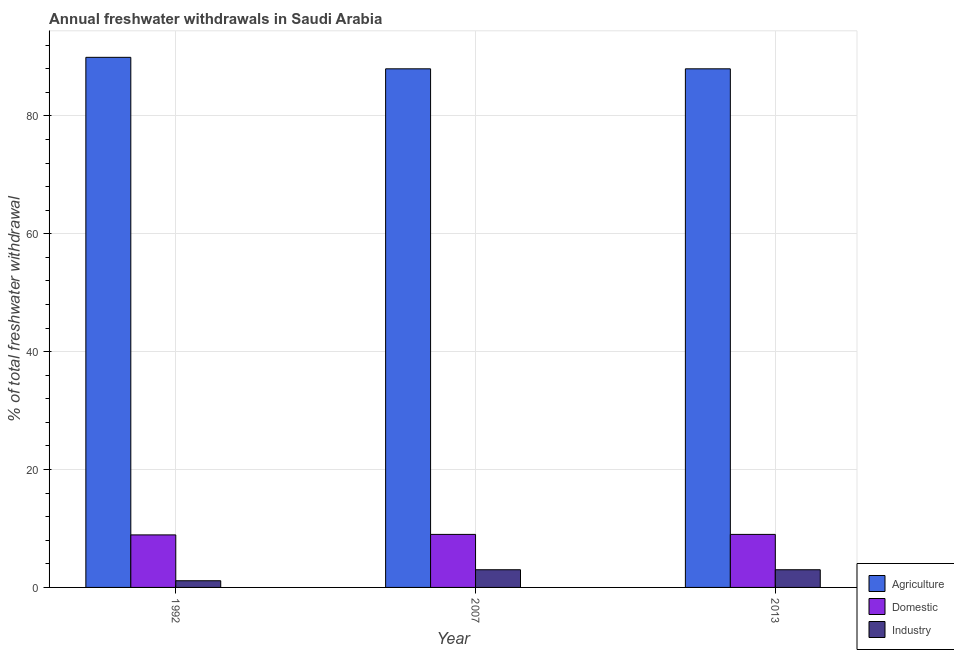How many different coloured bars are there?
Offer a very short reply. 3. Are the number of bars per tick equal to the number of legend labels?
Your response must be concise. Yes. How many bars are there on the 1st tick from the right?
Your answer should be compact. 3. What is the label of the 1st group of bars from the left?
Your response must be concise. 1992. In how many cases, is the number of bars for a given year not equal to the number of legend labels?
Your answer should be very brief. 0. Across all years, what is the maximum percentage of freshwater withdrawal for agriculture?
Keep it short and to the point. 89.95. Across all years, what is the minimum percentage of freshwater withdrawal for industry?
Make the answer very short. 1.13. In which year was the percentage of freshwater withdrawal for industry maximum?
Offer a terse response. 2007. What is the total percentage of freshwater withdrawal for industry in the graph?
Make the answer very short. 7.13. What is the difference between the percentage of freshwater withdrawal for agriculture in 1992 and that in 2013?
Provide a succinct answer. 1.95. What is the difference between the percentage of freshwater withdrawal for industry in 2007 and the percentage of freshwater withdrawal for domestic purposes in 2013?
Make the answer very short. 0. What is the average percentage of freshwater withdrawal for agriculture per year?
Make the answer very short. 88.65. What is the difference between the highest and the second highest percentage of freshwater withdrawal for industry?
Offer a very short reply. 0. What is the difference between the highest and the lowest percentage of freshwater withdrawal for industry?
Keep it short and to the point. 1.87. What does the 3rd bar from the left in 1992 represents?
Offer a terse response. Industry. What does the 3rd bar from the right in 1992 represents?
Your response must be concise. Agriculture. How many bars are there?
Make the answer very short. 9. How many years are there in the graph?
Offer a very short reply. 3. What is the difference between two consecutive major ticks on the Y-axis?
Your answer should be compact. 20. Does the graph contain any zero values?
Keep it short and to the point. No. Does the graph contain grids?
Offer a terse response. Yes. Where does the legend appear in the graph?
Make the answer very short. Bottom right. How many legend labels are there?
Your response must be concise. 3. What is the title of the graph?
Keep it short and to the point. Annual freshwater withdrawals in Saudi Arabia. What is the label or title of the Y-axis?
Provide a short and direct response. % of total freshwater withdrawal. What is the % of total freshwater withdrawal of Agriculture in 1992?
Provide a short and direct response. 89.95. What is the % of total freshwater withdrawal of Domestic in 1992?
Make the answer very short. 8.91. What is the % of total freshwater withdrawal of Industry in 1992?
Make the answer very short. 1.13. What is the % of total freshwater withdrawal of Agriculture in 2007?
Provide a succinct answer. 88. What is the % of total freshwater withdrawal of Domestic in 2007?
Ensure brevity in your answer.  9. What is the % of total freshwater withdrawal of Industry in 2007?
Keep it short and to the point. 3. What is the % of total freshwater withdrawal in Agriculture in 2013?
Offer a very short reply. 88. What is the % of total freshwater withdrawal of Domestic in 2013?
Make the answer very short. 9. What is the % of total freshwater withdrawal of Industry in 2013?
Make the answer very short. 3. Across all years, what is the maximum % of total freshwater withdrawal of Agriculture?
Provide a short and direct response. 89.95. Across all years, what is the maximum % of total freshwater withdrawal in Domestic?
Make the answer very short. 9. Across all years, what is the minimum % of total freshwater withdrawal in Agriculture?
Your answer should be very brief. 88. Across all years, what is the minimum % of total freshwater withdrawal of Domestic?
Your response must be concise. 8.91. Across all years, what is the minimum % of total freshwater withdrawal of Industry?
Give a very brief answer. 1.13. What is the total % of total freshwater withdrawal of Agriculture in the graph?
Provide a succinct answer. 265.95. What is the total % of total freshwater withdrawal of Domestic in the graph?
Provide a short and direct response. 26.91. What is the total % of total freshwater withdrawal of Industry in the graph?
Your answer should be compact. 7.13. What is the difference between the % of total freshwater withdrawal of Agriculture in 1992 and that in 2007?
Your answer should be very brief. 1.95. What is the difference between the % of total freshwater withdrawal of Domestic in 1992 and that in 2007?
Offer a terse response. -0.09. What is the difference between the % of total freshwater withdrawal in Industry in 1992 and that in 2007?
Your answer should be very brief. -1.87. What is the difference between the % of total freshwater withdrawal of Agriculture in 1992 and that in 2013?
Offer a terse response. 1.95. What is the difference between the % of total freshwater withdrawal in Domestic in 1992 and that in 2013?
Offer a terse response. -0.09. What is the difference between the % of total freshwater withdrawal of Industry in 1992 and that in 2013?
Offer a very short reply. -1.87. What is the difference between the % of total freshwater withdrawal of Agriculture in 2007 and that in 2013?
Provide a succinct answer. 0. What is the difference between the % of total freshwater withdrawal in Industry in 2007 and that in 2013?
Provide a short and direct response. 0. What is the difference between the % of total freshwater withdrawal in Agriculture in 1992 and the % of total freshwater withdrawal in Domestic in 2007?
Offer a very short reply. 80.95. What is the difference between the % of total freshwater withdrawal of Agriculture in 1992 and the % of total freshwater withdrawal of Industry in 2007?
Keep it short and to the point. 86.95. What is the difference between the % of total freshwater withdrawal in Domestic in 1992 and the % of total freshwater withdrawal in Industry in 2007?
Your answer should be very brief. 5.91. What is the difference between the % of total freshwater withdrawal of Agriculture in 1992 and the % of total freshwater withdrawal of Domestic in 2013?
Your answer should be very brief. 80.95. What is the difference between the % of total freshwater withdrawal of Agriculture in 1992 and the % of total freshwater withdrawal of Industry in 2013?
Your answer should be compact. 86.95. What is the difference between the % of total freshwater withdrawal in Domestic in 1992 and the % of total freshwater withdrawal in Industry in 2013?
Provide a succinct answer. 5.91. What is the difference between the % of total freshwater withdrawal in Agriculture in 2007 and the % of total freshwater withdrawal in Domestic in 2013?
Keep it short and to the point. 79. What is the difference between the % of total freshwater withdrawal in Domestic in 2007 and the % of total freshwater withdrawal in Industry in 2013?
Ensure brevity in your answer.  6. What is the average % of total freshwater withdrawal of Agriculture per year?
Provide a short and direct response. 88.65. What is the average % of total freshwater withdrawal of Domestic per year?
Provide a short and direct response. 8.97. What is the average % of total freshwater withdrawal of Industry per year?
Give a very brief answer. 2.38. In the year 1992, what is the difference between the % of total freshwater withdrawal in Agriculture and % of total freshwater withdrawal in Domestic?
Your response must be concise. 81.04. In the year 1992, what is the difference between the % of total freshwater withdrawal in Agriculture and % of total freshwater withdrawal in Industry?
Your answer should be very brief. 88.82. In the year 1992, what is the difference between the % of total freshwater withdrawal of Domestic and % of total freshwater withdrawal of Industry?
Provide a succinct answer. 7.78. In the year 2007, what is the difference between the % of total freshwater withdrawal in Agriculture and % of total freshwater withdrawal in Domestic?
Provide a succinct answer. 79. In the year 2007, what is the difference between the % of total freshwater withdrawal in Agriculture and % of total freshwater withdrawal in Industry?
Provide a short and direct response. 85. In the year 2007, what is the difference between the % of total freshwater withdrawal in Domestic and % of total freshwater withdrawal in Industry?
Provide a succinct answer. 6. In the year 2013, what is the difference between the % of total freshwater withdrawal in Agriculture and % of total freshwater withdrawal in Domestic?
Offer a very short reply. 79. In the year 2013, what is the difference between the % of total freshwater withdrawal in Agriculture and % of total freshwater withdrawal in Industry?
Provide a short and direct response. 85. In the year 2013, what is the difference between the % of total freshwater withdrawal in Domestic and % of total freshwater withdrawal in Industry?
Make the answer very short. 6. What is the ratio of the % of total freshwater withdrawal in Agriculture in 1992 to that in 2007?
Ensure brevity in your answer.  1.02. What is the ratio of the % of total freshwater withdrawal of Industry in 1992 to that in 2007?
Your answer should be compact. 0.38. What is the ratio of the % of total freshwater withdrawal in Agriculture in 1992 to that in 2013?
Provide a succinct answer. 1.02. What is the ratio of the % of total freshwater withdrawal of Industry in 1992 to that in 2013?
Your answer should be very brief. 0.38. What is the ratio of the % of total freshwater withdrawal in Industry in 2007 to that in 2013?
Give a very brief answer. 1. What is the difference between the highest and the second highest % of total freshwater withdrawal in Agriculture?
Your answer should be very brief. 1.95. What is the difference between the highest and the second highest % of total freshwater withdrawal in Domestic?
Your response must be concise. 0. What is the difference between the highest and the lowest % of total freshwater withdrawal in Agriculture?
Offer a terse response. 1.95. What is the difference between the highest and the lowest % of total freshwater withdrawal in Domestic?
Provide a short and direct response. 0.09. What is the difference between the highest and the lowest % of total freshwater withdrawal of Industry?
Make the answer very short. 1.87. 